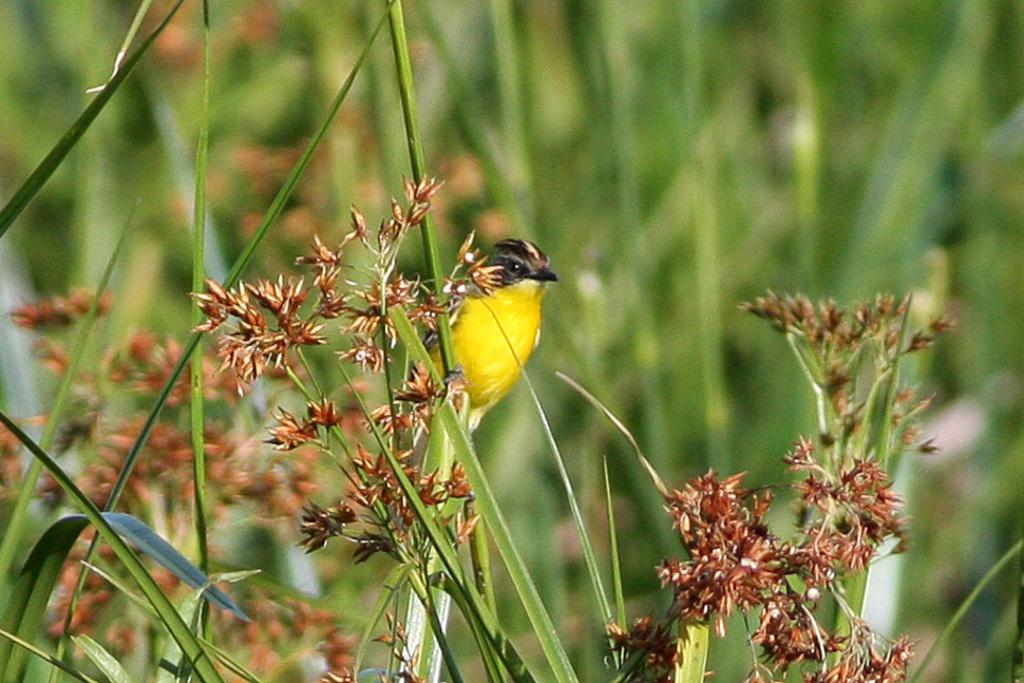What type of vegetation is present in the image? There is grass with flowers in the image. What animal can be seen in the image? There is a bird in the image. Can you describe the background of the image? The background of the image is blurry. What type of crown is the bird wearing in the image? There is no crown present in the image, and the bird is not wearing any accessories. 